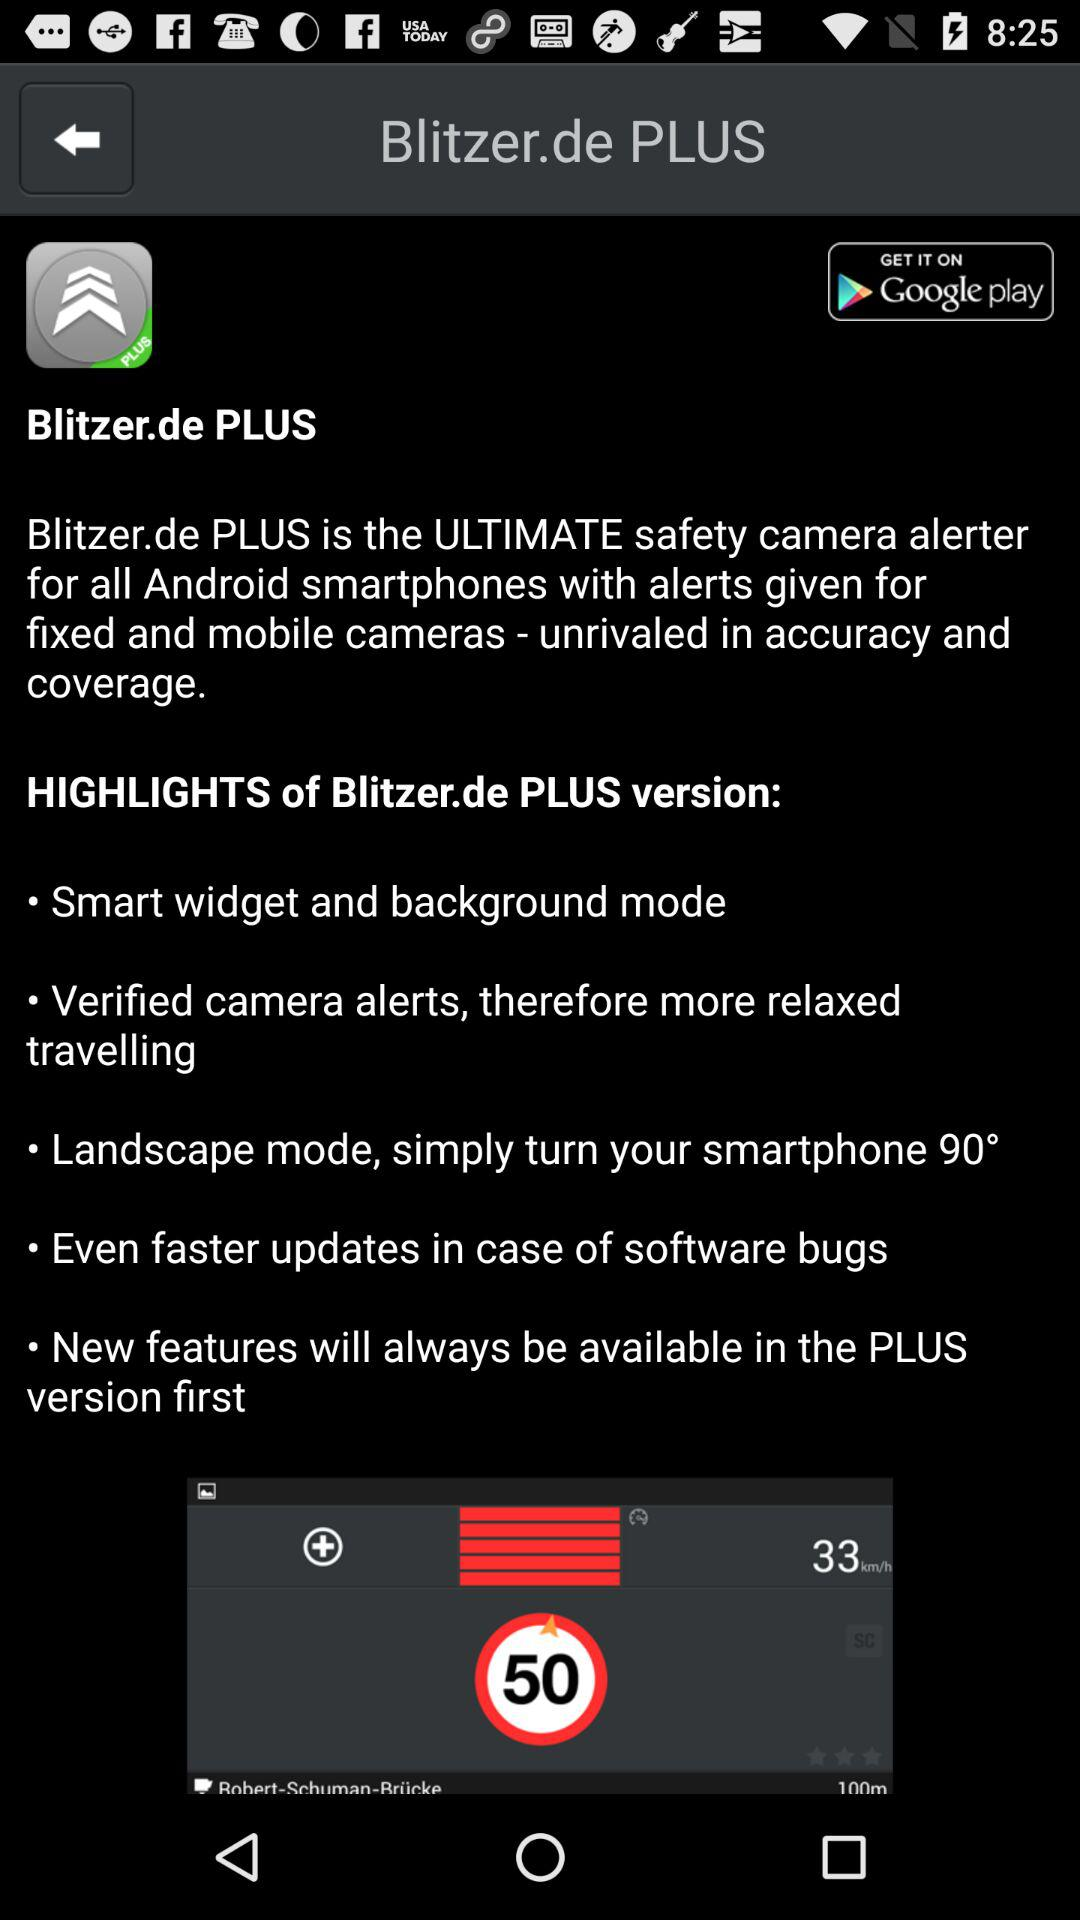Where can we download this app? You can download this app from Google Play. 